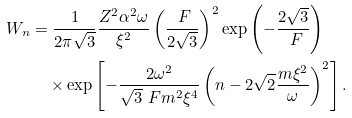Convert formula to latex. <formula><loc_0><loc_0><loc_500><loc_500>W _ { n } & = \frac { 1 } { 2 \pi \sqrt { 3 } } \frac { Z ^ { 2 } \alpha ^ { 2 } \omega } { \xi ^ { 2 } } \left ( \frac { \ F } { 2 \sqrt { 3 } } \right ) ^ { 2 } \exp \left ( - \frac { 2 \sqrt { 3 } } { \ F } \right ) \\ & \quad \times \exp \left [ - \frac { 2 \omega ^ { 2 } } { \sqrt { 3 } \ F m ^ { 2 } \xi ^ { 4 } } \left ( n - 2 \sqrt { 2 } \frac { m \xi ^ { 2 } } { \omega } \right ) ^ { 2 } \right ] .</formula> 